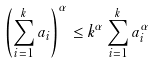Convert formula to latex. <formula><loc_0><loc_0><loc_500><loc_500>\left ( \sum _ { i = 1 } ^ { k } a _ { i } \right ) ^ { \alpha } \leq k ^ { \alpha } \sum _ { i = 1 } ^ { k } a _ { i } ^ { \alpha }</formula> 